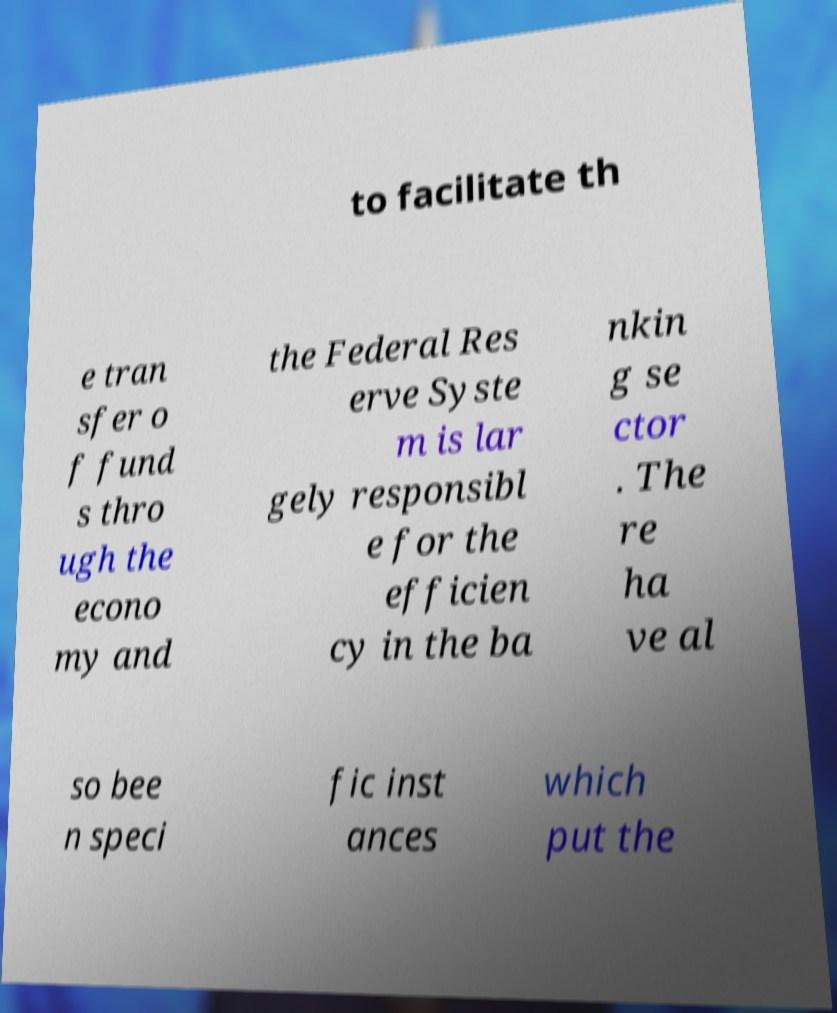Could you assist in decoding the text presented in this image and type it out clearly? to facilitate th e tran sfer o f fund s thro ugh the econo my and the Federal Res erve Syste m is lar gely responsibl e for the efficien cy in the ba nkin g se ctor . The re ha ve al so bee n speci fic inst ances which put the 